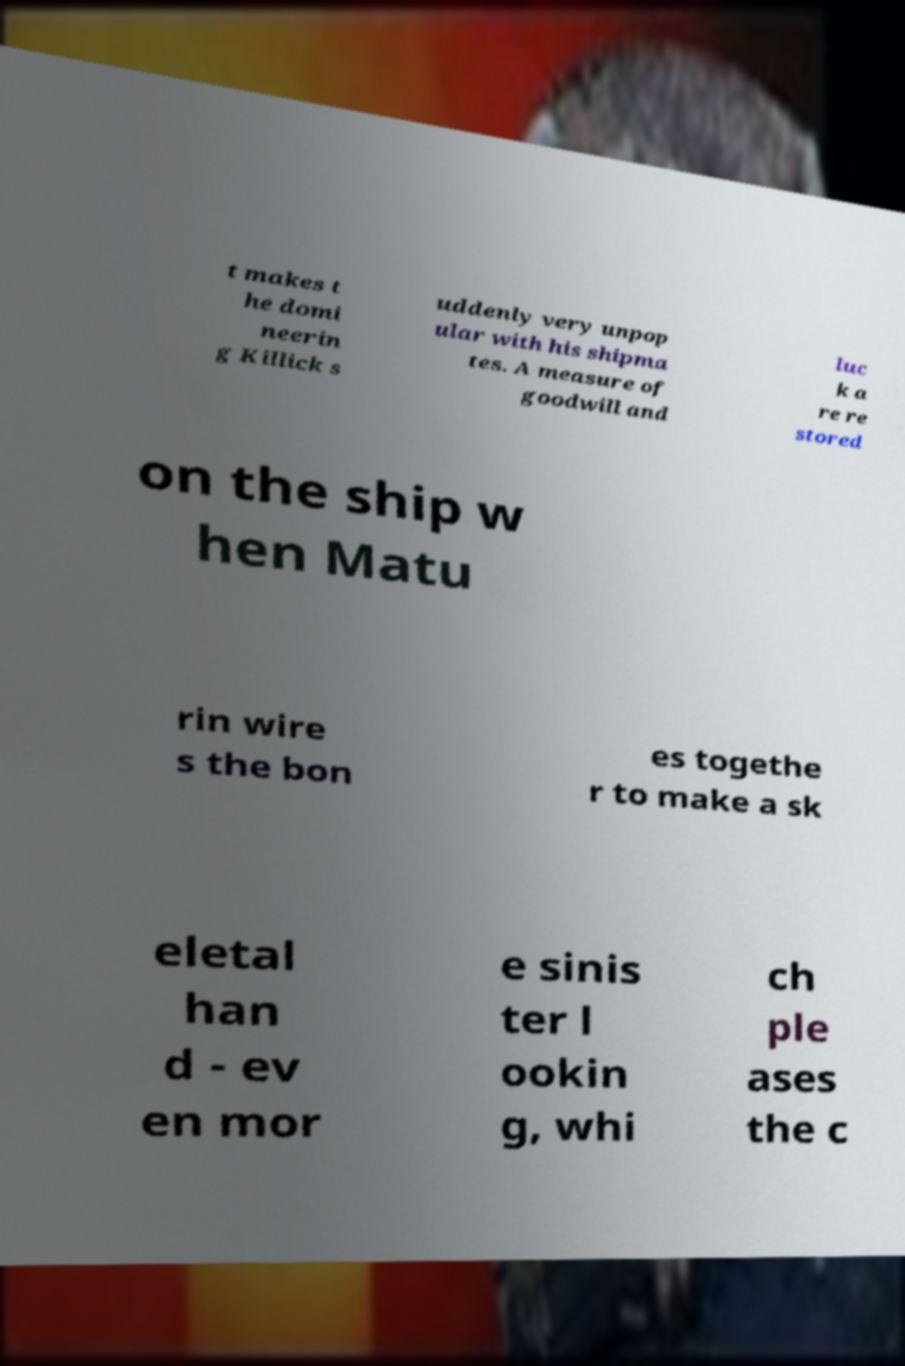Can you accurately transcribe the text from the provided image for me? t makes t he domi neerin g Killick s uddenly very unpop ular with his shipma tes. A measure of goodwill and luc k a re re stored on the ship w hen Matu rin wire s the bon es togethe r to make a sk eletal han d - ev en mor e sinis ter l ookin g, whi ch ple ases the c 